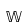Convert formula to latex. <formula><loc_0><loc_0><loc_500><loc_500>\mathbb { W }</formula> 